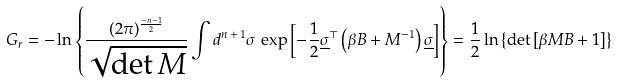<formula> <loc_0><loc_0><loc_500><loc_500>G _ { r } = - \ln \left \{ \frac { ( 2 \pi ) ^ { \frac { - n - 1 } { 2 } } } { \sqrt { \det M } } \int d ^ { n \, + \, 1 } \sigma \, \exp \left [ { - \frac { 1 } { 2 } \underline { \sigma } ^ { \top } \left ( { \beta B + M ^ { - 1 } } \right ) \underline { \sigma } } \right ] \right \} = \frac { 1 } { 2 } \ln \left \{ \det \left [ { \beta M B + 1 } \right ] \right \}</formula> 